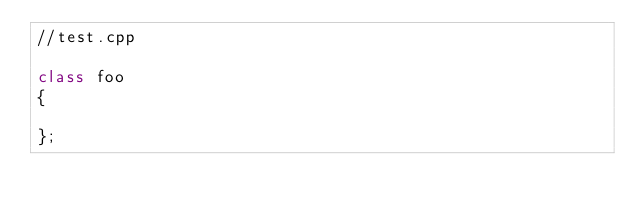Convert code to text. <code><loc_0><loc_0><loc_500><loc_500><_C++_>//test.cpp

class foo
{

};


</code> 